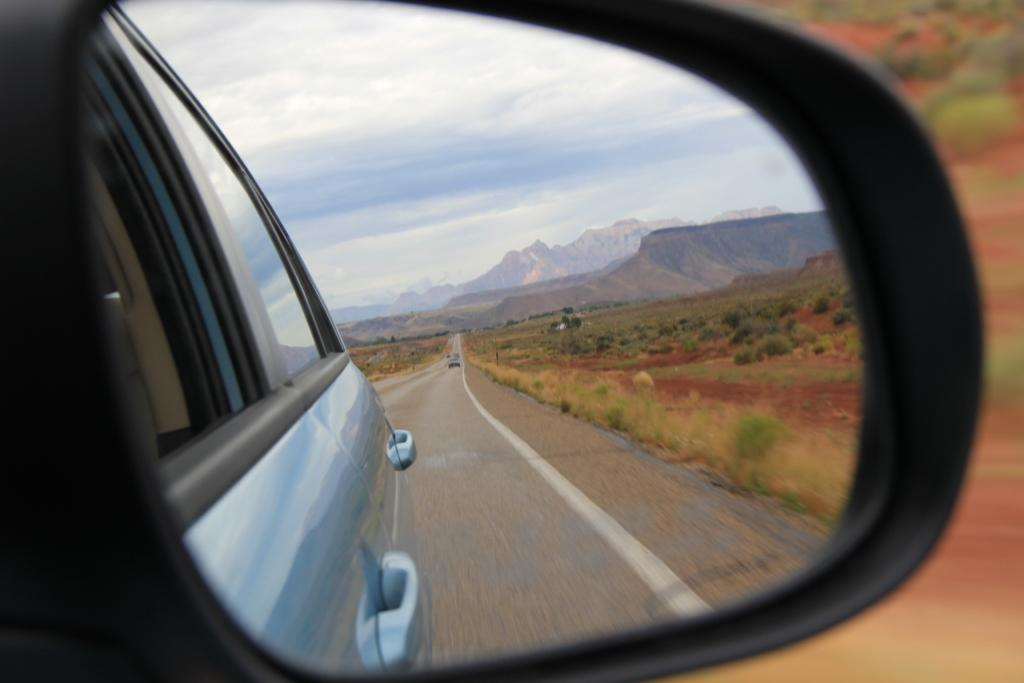What can be seen on the road in the image? There are mirror images of vehicles on the road. What type of vegetation is present in the image? There are plants and grass in the image. What natural feature can be seen in the background of the image? There are mountains in the image. What part of the natural environment is visible in the image? The sky is visible in the image. What type of wall can be seen in the image? There is no wall present in the image. What color is the curtain in the image? There is no curtain present in the image. 